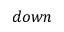<formula> <loc_0><loc_0><loc_500><loc_500>d o w n</formula> 